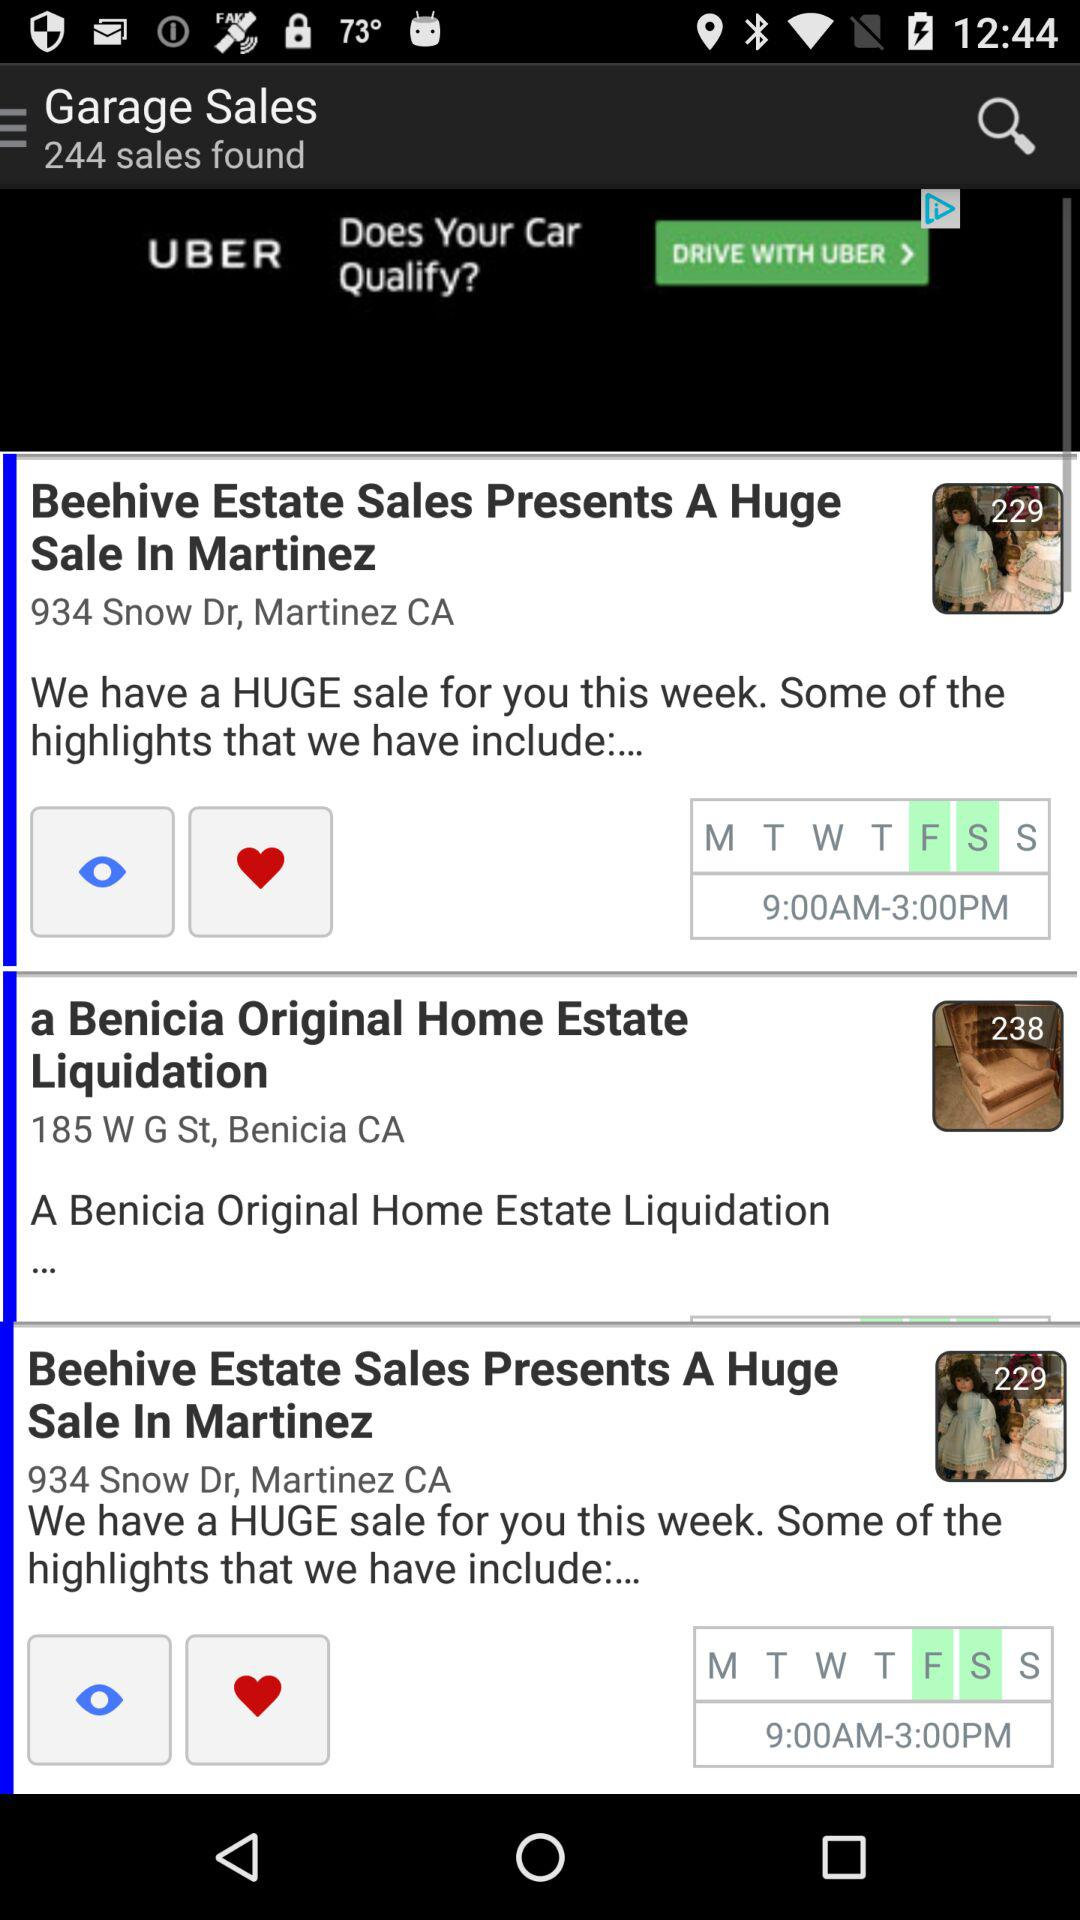How many sales were found in total? There were 244 sales found in total. 